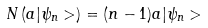<formula> <loc_0><loc_0><loc_500><loc_500>N \left ( a | \psi _ { n } > \right ) = ( n - 1 ) a | \psi _ { n } ></formula> 